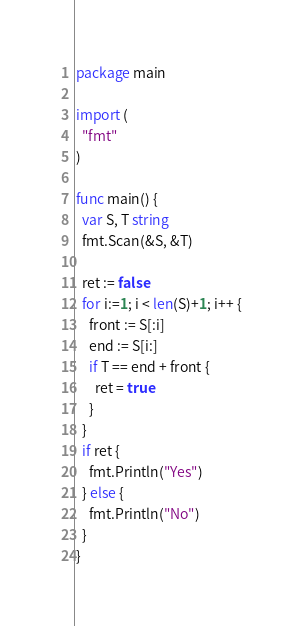<code> <loc_0><loc_0><loc_500><loc_500><_Go_>package main 

import (
  "fmt"
)

func main() {
  var S, T string
  fmt.Scan(&S, &T)
  
  ret := false
  for i:=1; i < len(S)+1; i++ {
    front := S[:i]
    end := S[i:]
    if T == end + front {
      ret = true
    }
  }
  if ret {
    fmt.Println("Yes")
  } else {
    fmt.Println("No")
  }
}</code> 